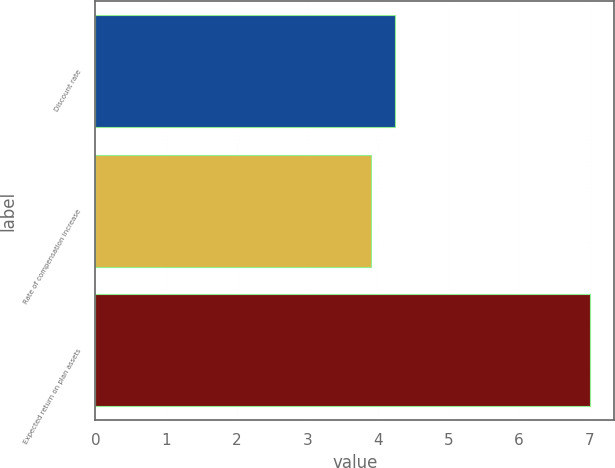Convert chart to OTSL. <chart><loc_0><loc_0><loc_500><loc_500><bar_chart><fcel>Discount rate<fcel>Rate of compensation increase<fcel>Expected return on plan assets<nl><fcel>4.25<fcel>3.91<fcel>7<nl></chart> 